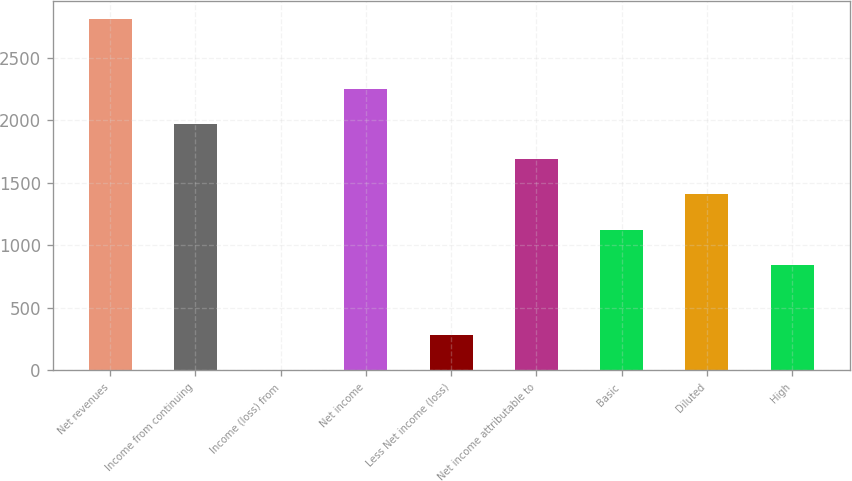<chart> <loc_0><loc_0><loc_500><loc_500><bar_chart><fcel>Net revenues<fcel>Income from continuing<fcel>Income (loss) from<fcel>Net income<fcel>Less Net income (loss)<fcel>Net income attributable to<fcel>Basic<fcel>Diluted<fcel>High<nl><fcel>2813<fcel>1969.4<fcel>1<fcel>2250.6<fcel>282.2<fcel>1688.2<fcel>1125.8<fcel>1407<fcel>844.6<nl></chart> 